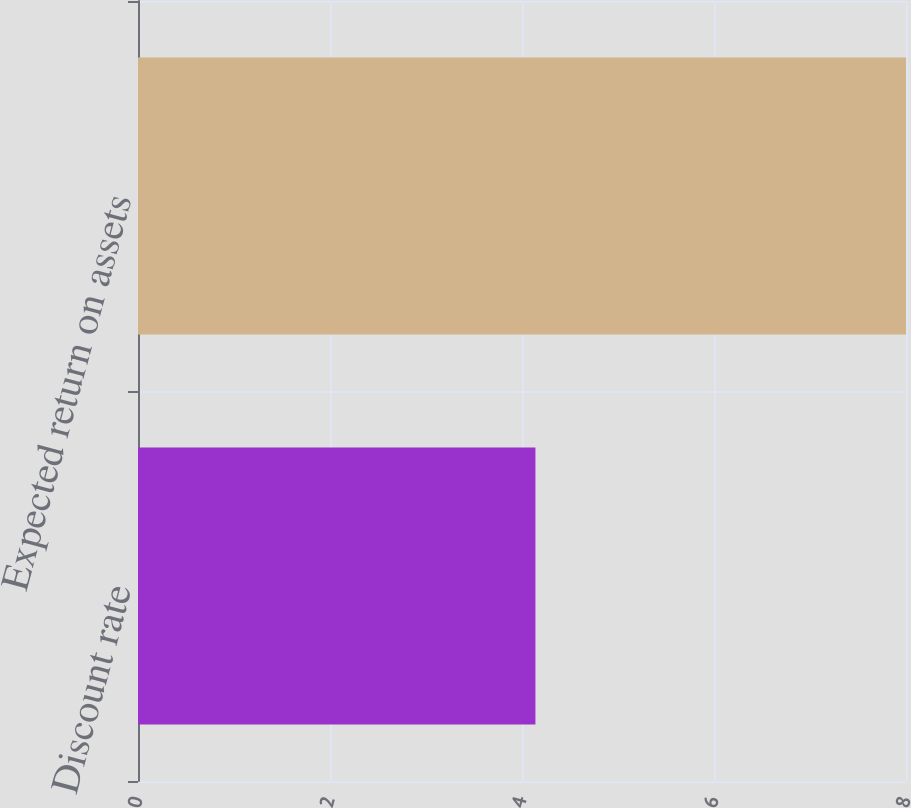Convert chart to OTSL. <chart><loc_0><loc_0><loc_500><loc_500><bar_chart><fcel>Discount rate<fcel>Expected return on assets<nl><fcel>4.14<fcel>8<nl></chart> 